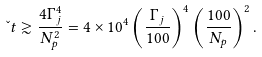Convert formula to latex. <formula><loc_0><loc_0><loc_500><loc_500>\L t \gtrsim \frac { 4 \Gamma _ { j } ^ { 4 } } { N _ { p } ^ { 2 } } = 4 \times 1 0 ^ { 4 } \left ( \frac { \Gamma _ { j } } { 1 0 0 } \right ) ^ { 4 } \left ( \frac { 1 0 0 } { N _ { p } } \right ) ^ { 2 } .</formula> 